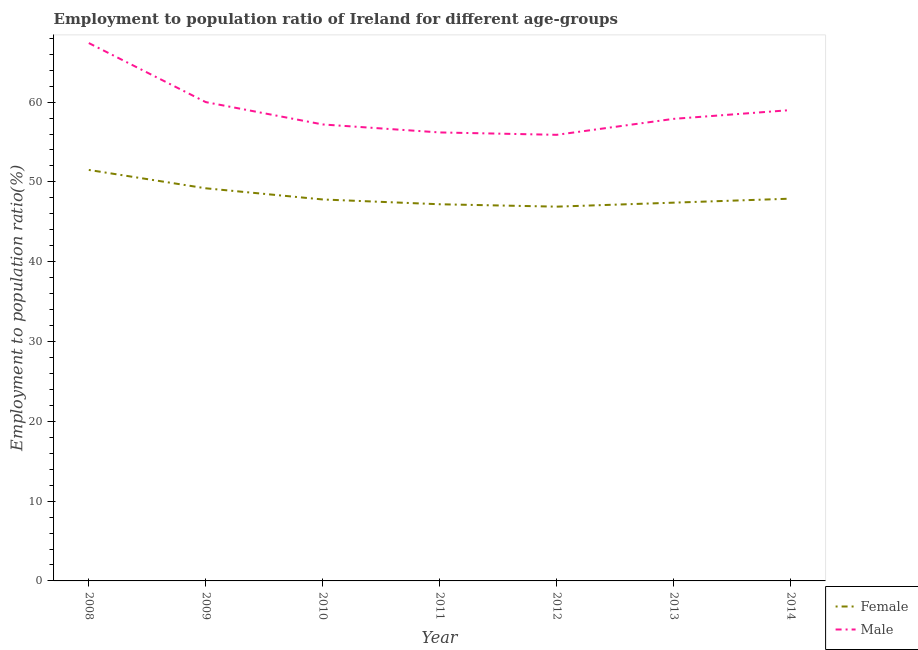Does the line corresponding to employment to population ratio(male) intersect with the line corresponding to employment to population ratio(female)?
Your response must be concise. No. What is the employment to population ratio(male) in 2013?
Your answer should be very brief. 57.9. Across all years, what is the maximum employment to population ratio(male)?
Provide a short and direct response. 67.4. Across all years, what is the minimum employment to population ratio(male)?
Your answer should be compact. 55.9. In which year was the employment to population ratio(female) maximum?
Make the answer very short. 2008. In which year was the employment to population ratio(male) minimum?
Provide a succinct answer. 2012. What is the total employment to population ratio(male) in the graph?
Offer a terse response. 413.6. What is the difference between the employment to population ratio(male) in 2008 and that in 2012?
Keep it short and to the point. 11.5. What is the difference between the employment to population ratio(female) in 2009 and the employment to population ratio(male) in 2008?
Give a very brief answer. -18.2. What is the average employment to population ratio(female) per year?
Make the answer very short. 48.27. In how many years, is the employment to population ratio(male) greater than 48 %?
Provide a short and direct response. 7. What is the ratio of the employment to population ratio(female) in 2012 to that in 2014?
Offer a very short reply. 0.98. What is the difference between the highest and the second highest employment to population ratio(female)?
Provide a succinct answer. 2.3. What is the difference between the highest and the lowest employment to population ratio(male)?
Your answer should be very brief. 11.5. Is the sum of the employment to population ratio(female) in 2012 and 2013 greater than the maximum employment to population ratio(male) across all years?
Make the answer very short. Yes. Is the employment to population ratio(female) strictly greater than the employment to population ratio(male) over the years?
Offer a very short reply. No. How many lines are there?
Provide a short and direct response. 2. How many years are there in the graph?
Offer a terse response. 7. Are the values on the major ticks of Y-axis written in scientific E-notation?
Give a very brief answer. No. Does the graph contain any zero values?
Provide a succinct answer. No. Where does the legend appear in the graph?
Ensure brevity in your answer.  Bottom right. How many legend labels are there?
Your answer should be compact. 2. What is the title of the graph?
Offer a very short reply. Employment to population ratio of Ireland for different age-groups. What is the label or title of the X-axis?
Ensure brevity in your answer.  Year. What is the label or title of the Y-axis?
Keep it short and to the point. Employment to population ratio(%). What is the Employment to population ratio(%) of Female in 2008?
Your answer should be very brief. 51.5. What is the Employment to population ratio(%) of Male in 2008?
Provide a short and direct response. 67.4. What is the Employment to population ratio(%) of Female in 2009?
Your answer should be compact. 49.2. What is the Employment to population ratio(%) in Male in 2009?
Your response must be concise. 60. What is the Employment to population ratio(%) in Female in 2010?
Offer a terse response. 47.8. What is the Employment to population ratio(%) in Male in 2010?
Offer a very short reply. 57.2. What is the Employment to population ratio(%) of Female in 2011?
Make the answer very short. 47.2. What is the Employment to population ratio(%) of Male in 2011?
Provide a short and direct response. 56.2. What is the Employment to population ratio(%) of Female in 2012?
Make the answer very short. 46.9. What is the Employment to population ratio(%) of Male in 2012?
Your answer should be very brief. 55.9. What is the Employment to population ratio(%) of Female in 2013?
Your response must be concise. 47.4. What is the Employment to population ratio(%) in Male in 2013?
Make the answer very short. 57.9. What is the Employment to population ratio(%) of Female in 2014?
Your answer should be compact. 47.9. What is the Employment to population ratio(%) in Male in 2014?
Ensure brevity in your answer.  59. Across all years, what is the maximum Employment to population ratio(%) in Female?
Your answer should be compact. 51.5. Across all years, what is the maximum Employment to population ratio(%) of Male?
Offer a very short reply. 67.4. Across all years, what is the minimum Employment to population ratio(%) of Female?
Keep it short and to the point. 46.9. Across all years, what is the minimum Employment to population ratio(%) of Male?
Make the answer very short. 55.9. What is the total Employment to population ratio(%) in Female in the graph?
Your answer should be very brief. 337.9. What is the total Employment to population ratio(%) in Male in the graph?
Offer a very short reply. 413.6. What is the difference between the Employment to population ratio(%) in Male in 2008 and that in 2009?
Your response must be concise. 7.4. What is the difference between the Employment to population ratio(%) in Female in 2008 and that in 2010?
Provide a succinct answer. 3.7. What is the difference between the Employment to population ratio(%) in Female in 2008 and that in 2012?
Your response must be concise. 4.6. What is the difference between the Employment to population ratio(%) in Female in 2008 and that in 2013?
Provide a short and direct response. 4.1. What is the difference between the Employment to population ratio(%) in Male in 2008 and that in 2013?
Your answer should be compact. 9.5. What is the difference between the Employment to population ratio(%) of Female in 2008 and that in 2014?
Your answer should be very brief. 3.6. What is the difference between the Employment to population ratio(%) of Male in 2009 and that in 2010?
Ensure brevity in your answer.  2.8. What is the difference between the Employment to population ratio(%) of Female in 2009 and that in 2011?
Your answer should be very brief. 2. What is the difference between the Employment to population ratio(%) of Male in 2009 and that in 2011?
Offer a terse response. 3.8. What is the difference between the Employment to population ratio(%) in Male in 2009 and that in 2012?
Provide a short and direct response. 4.1. What is the difference between the Employment to population ratio(%) of Female in 2009 and that in 2013?
Keep it short and to the point. 1.8. What is the difference between the Employment to population ratio(%) of Male in 2009 and that in 2013?
Your answer should be compact. 2.1. What is the difference between the Employment to population ratio(%) in Female in 2009 and that in 2014?
Make the answer very short. 1.3. What is the difference between the Employment to population ratio(%) in Female in 2010 and that in 2011?
Offer a very short reply. 0.6. What is the difference between the Employment to population ratio(%) in Female in 2010 and that in 2013?
Offer a very short reply. 0.4. What is the difference between the Employment to population ratio(%) in Male in 2010 and that in 2013?
Give a very brief answer. -0.7. What is the difference between the Employment to population ratio(%) in Female in 2010 and that in 2014?
Make the answer very short. -0.1. What is the difference between the Employment to population ratio(%) in Female in 2011 and that in 2012?
Keep it short and to the point. 0.3. What is the difference between the Employment to population ratio(%) in Male in 2011 and that in 2013?
Give a very brief answer. -1.7. What is the difference between the Employment to population ratio(%) in Female in 2011 and that in 2014?
Make the answer very short. -0.7. What is the difference between the Employment to population ratio(%) of Male in 2011 and that in 2014?
Your answer should be very brief. -2.8. What is the difference between the Employment to population ratio(%) in Male in 2012 and that in 2013?
Offer a terse response. -2. What is the difference between the Employment to population ratio(%) in Female in 2012 and that in 2014?
Your response must be concise. -1. What is the difference between the Employment to population ratio(%) in Male in 2012 and that in 2014?
Provide a short and direct response. -3.1. What is the difference between the Employment to population ratio(%) of Female in 2013 and that in 2014?
Make the answer very short. -0.5. What is the difference between the Employment to population ratio(%) of Female in 2008 and the Employment to population ratio(%) of Male in 2011?
Ensure brevity in your answer.  -4.7. What is the difference between the Employment to population ratio(%) of Female in 2008 and the Employment to population ratio(%) of Male in 2013?
Your answer should be very brief. -6.4. What is the difference between the Employment to population ratio(%) of Female in 2008 and the Employment to population ratio(%) of Male in 2014?
Provide a succinct answer. -7.5. What is the difference between the Employment to population ratio(%) of Female in 2009 and the Employment to population ratio(%) of Male in 2010?
Your response must be concise. -8. What is the difference between the Employment to population ratio(%) in Female in 2010 and the Employment to population ratio(%) in Male in 2011?
Ensure brevity in your answer.  -8.4. What is the difference between the Employment to population ratio(%) of Female in 2010 and the Employment to population ratio(%) of Male in 2012?
Offer a terse response. -8.1. What is the difference between the Employment to population ratio(%) in Female in 2010 and the Employment to population ratio(%) in Male in 2013?
Your answer should be very brief. -10.1. What is the difference between the Employment to population ratio(%) in Female in 2011 and the Employment to population ratio(%) in Male in 2012?
Offer a terse response. -8.7. What is the difference between the Employment to population ratio(%) of Female in 2011 and the Employment to population ratio(%) of Male in 2013?
Your answer should be compact. -10.7. What is the difference between the Employment to population ratio(%) in Female in 2012 and the Employment to population ratio(%) in Male in 2014?
Offer a terse response. -12.1. What is the average Employment to population ratio(%) in Female per year?
Offer a terse response. 48.27. What is the average Employment to population ratio(%) of Male per year?
Offer a very short reply. 59.09. In the year 2008, what is the difference between the Employment to population ratio(%) of Female and Employment to population ratio(%) of Male?
Your answer should be very brief. -15.9. In the year 2009, what is the difference between the Employment to population ratio(%) of Female and Employment to population ratio(%) of Male?
Your answer should be compact. -10.8. In the year 2013, what is the difference between the Employment to population ratio(%) of Female and Employment to population ratio(%) of Male?
Provide a succinct answer. -10.5. What is the ratio of the Employment to population ratio(%) in Female in 2008 to that in 2009?
Keep it short and to the point. 1.05. What is the ratio of the Employment to population ratio(%) in Male in 2008 to that in 2009?
Offer a very short reply. 1.12. What is the ratio of the Employment to population ratio(%) of Female in 2008 to that in 2010?
Your answer should be compact. 1.08. What is the ratio of the Employment to population ratio(%) of Male in 2008 to that in 2010?
Provide a short and direct response. 1.18. What is the ratio of the Employment to population ratio(%) in Female in 2008 to that in 2011?
Your answer should be compact. 1.09. What is the ratio of the Employment to population ratio(%) in Male in 2008 to that in 2011?
Your response must be concise. 1.2. What is the ratio of the Employment to population ratio(%) in Female in 2008 to that in 2012?
Provide a succinct answer. 1.1. What is the ratio of the Employment to population ratio(%) in Male in 2008 to that in 2012?
Give a very brief answer. 1.21. What is the ratio of the Employment to population ratio(%) in Female in 2008 to that in 2013?
Keep it short and to the point. 1.09. What is the ratio of the Employment to population ratio(%) of Male in 2008 to that in 2013?
Your answer should be very brief. 1.16. What is the ratio of the Employment to population ratio(%) of Female in 2008 to that in 2014?
Make the answer very short. 1.08. What is the ratio of the Employment to population ratio(%) of Male in 2008 to that in 2014?
Offer a terse response. 1.14. What is the ratio of the Employment to population ratio(%) in Female in 2009 to that in 2010?
Your response must be concise. 1.03. What is the ratio of the Employment to population ratio(%) in Male in 2009 to that in 2010?
Ensure brevity in your answer.  1.05. What is the ratio of the Employment to population ratio(%) of Female in 2009 to that in 2011?
Offer a terse response. 1.04. What is the ratio of the Employment to population ratio(%) in Male in 2009 to that in 2011?
Your answer should be compact. 1.07. What is the ratio of the Employment to population ratio(%) of Female in 2009 to that in 2012?
Make the answer very short. 1.05. What is the ratio of the Employment to population ratio(%) in Male in 2009 to that in 2012?
Your answer should be very brief. 1.07. What is the ratio of the Employment to population ratio(%) in Female in 2009 to that in 2013?
Provide a succinct answer. 1.04. What is the ratio of the Employment to population ratio(%) in Male in 2009 to that in 2013?
Your response must be concise. 1.04. What is the ratio of the Employment to population ratio(%) in Female in 2009 to that in 2014?
Make the answer very short. 1.03. What is the ratio of the Employment to population ratio(%) of Male in 2009 to that in 2014?
Ensure brevity in your answer.  1.02. What is the ratio of the Employment to population ratio(%) in Female in 2010 to that in 2011?
Provide a succinct answer. 1.01. What is the ratio of the Employment to population ratio(%) in Male in 2010 to that in 2011?
Provide a short and direct response. 1.02. What is the ratio of the Employment to population ratio(%) of Female in 2010 to that in 2012?
Offer a very short reply. 1.02. What is the ratio of the Employment to population ratio(%) of Male in 2010 to that in 2012?
Give a very brief answer. 1.02. What is the ratio of the Employment to population ratio(%) in Female in 2010 to that in 2013?
Keep it short and to the point. 1.01. What is the ratio of the Employment to population ratio(%) in Male in 2010 to that in 2013?
Your answer should be compact. 0.99. What is the ratio of the Employment to population ratio(%) in Female in 2010 to that in 2014?
Provide a short and direct response. 1. What is the ratio of the Employment to population ratio(%) in Male in 2010 to that in 2014?
Give a very brief answer. 0.97. What is the ratio of the Employment to population ratio(%) of Female in 2011 to that in 2012?
Keep it short and to the point. 1.01. What is the ratio of the Employment to population ratio(%) in Male in 2011 to that in 2012?
Offer a terse response. 1.01. What is the ratio of the Employment to population ratio(%) of Male in 2011 to that in 2013?
Your response must be concise. 0.97. What is the ratio of the Employment to population ratio(%) of Female in 2011 to that in 2014?
Provide a succinct answer. 0.99. What is the ratio of the Employment to population ratio(%) of Male in 2011 to that in 2014?
Provide a succinct answer. 0.95. What is the ratio of the Employment to population ratio(%) in Female in 2012 to that in 2013?
Your response must be concise. 0.99. What is the ratio of the Employment to population ratio(%) in Male in 2012 to that in 2013?
Offer a very short reply. 0.97. What is the ratio of the Employment to population ratio(%) of Female in 2012 to that in 2014?
Offer a very short reply. 0.98. What is the ratio of the Employment to population ratio(%) in Male in 2012 to that in 2014?
Ensure brevity in your answer.  0.95. What is the ratio of the Employment to population ratio(%) of Male in 2013 to that in 2014?
Keep it short and to the point. 0.98. What is the difference between the highest and the second highest Employment to population ratio(%) in Female?
Give a very brief answer. 2.3. What is the difference between the highest and the second highest Employment to population ratio(%) of Male?
Your answer should be compact. 7.4. What is the difference between the highest and the lowest Employment to population ratio(%) in Male?
Your answer should be compact. 11.5. 